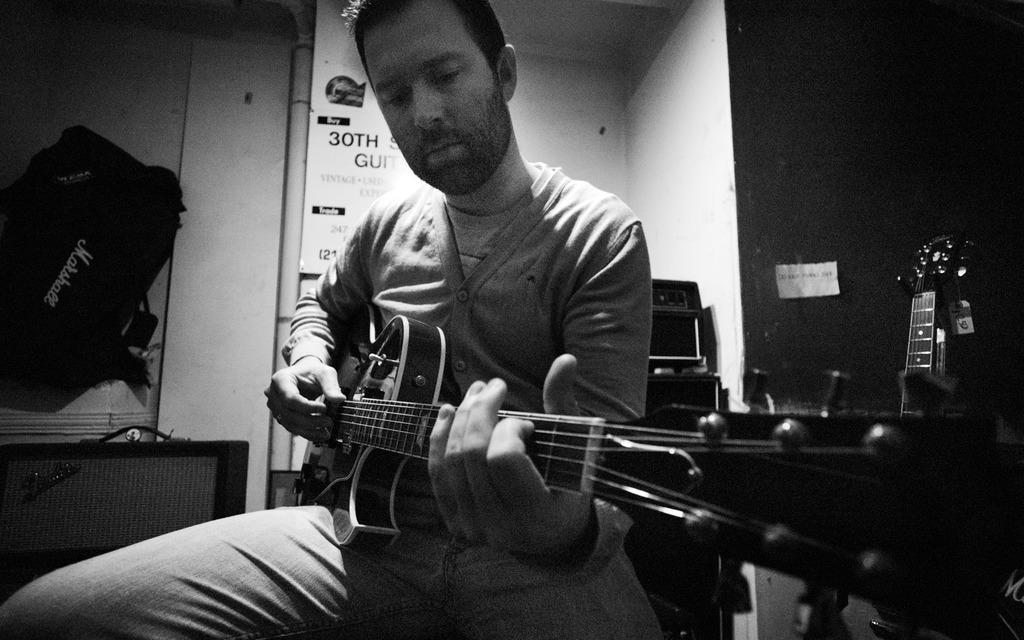Who is present in the image? There is a man in the image. What is the man doing in the image? The man is sitting in the image. What object is the man holding in the image? The man is holding a guitar in the image. What can be seen in the background of the image? There is a wall and a bag in the background of the image. Can you see the man kicking a ball in the image? There is no ball present in the image, and the man is sitting, so he is not kicking anything. 